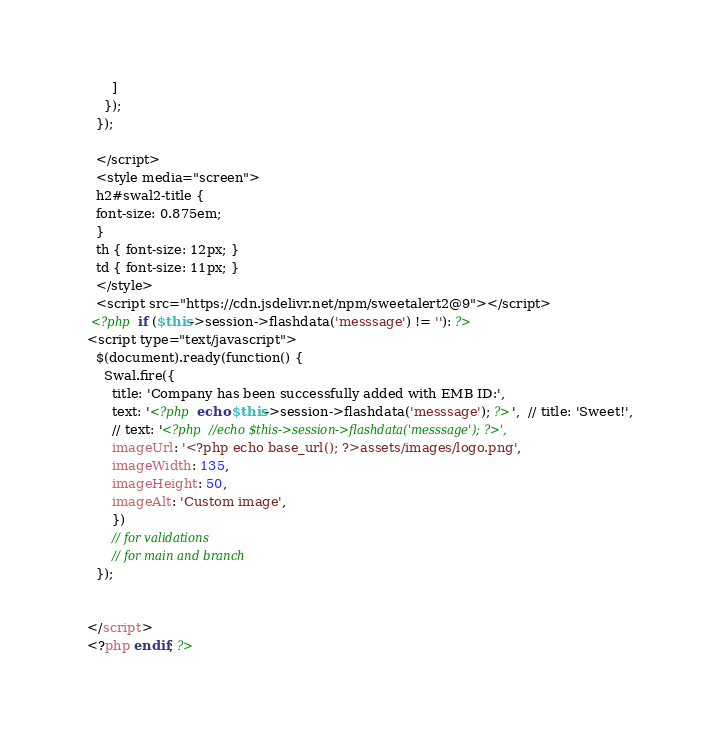Convert code to text. <code><loc_0><loc_0><loc_500><loc_500><_PHP_>        ]
      });
    });

    </script>
    <style media="screen">
    h2#swal2-title {
    font-size: 0.875em;
    }
    th { font-size: 12px; }
    td { font-size: 11px; }
    </style>
    <script src="https://cdn.jsdelivr.net/npm/sweetalert2@9"></script>
   <?php if ($this->session->flashdata('messsage') != ''): ?>
  <script type="text/javascript">
    $(document).ready(function() {
      Swal.fire({
        title: 'Company has been successfully added with EMB ID:',
        text: '<?php echo $this->session->flashdata('messsage'); ?>',  // title: 'Sweet!',
        // text: '<?php //echo $this->session->flashdata('messsage'); ?>',
        imageUrl: '<?php echo base_url(); ?>assets/images/logo.png',
        imageWidth: 135,
        imageHeight: 50,
        imageAlt: 'Custom image',
        })
        // for validations
        // for main and branch
    });


  </script>
  <?php endif; ?>
</code> 